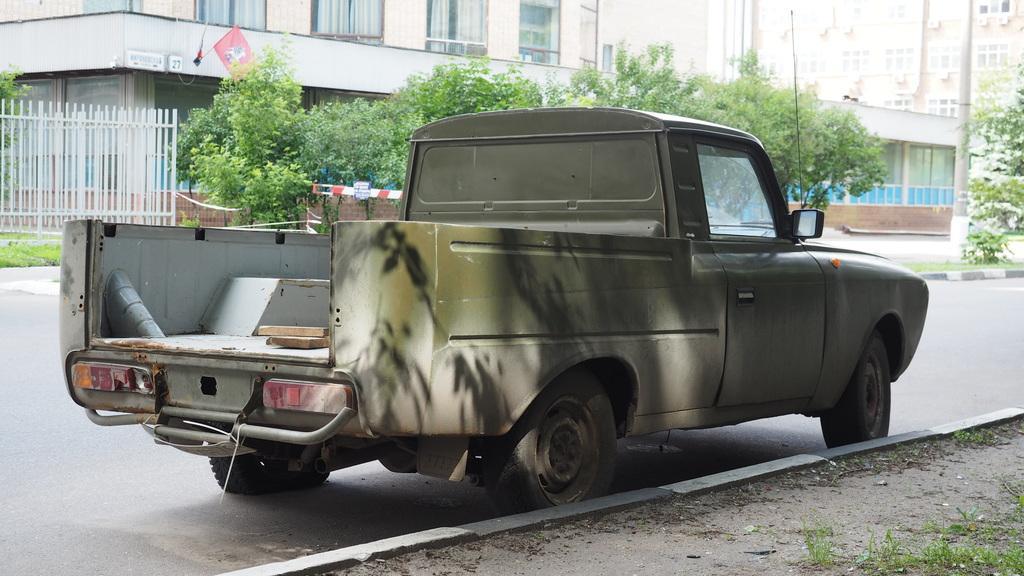In one or two sentences, can you explain what this image depicts? This picture shows a mini truck on the road and we see few buildings and trees and we see a flag to the building and a metal fence and couple of poles. 